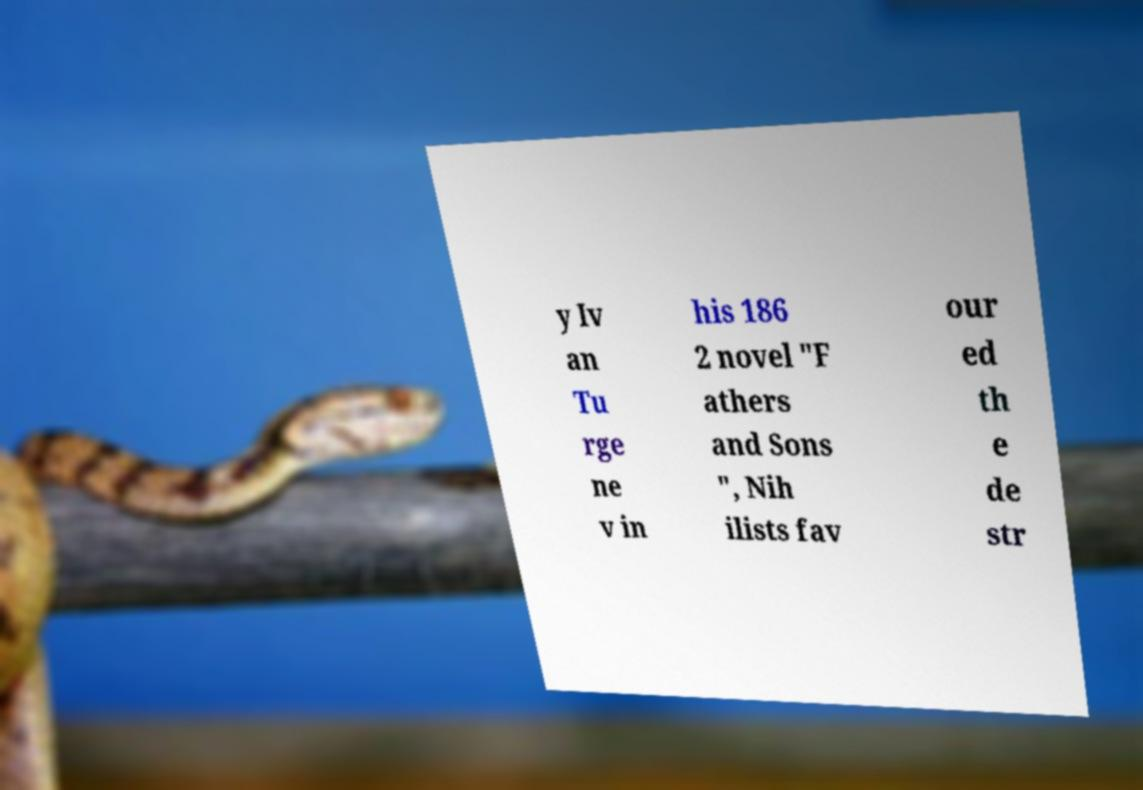Please read and relay the text visible in this image. What does it say? y Iv an Tu rge ne v in his 186 2 novel "F athers and Sons ", Nih ilists fav our ed th e de str 